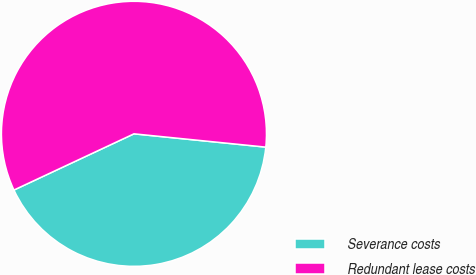Convert chart to OTSL. <chart><loc_0><loc_0><loc_500><loc_500><pie_chart><fcel>Severance costs<fcel>Redundant lease costs<nl><fcel>41.43%<fcel>58.57%<nl></chart> 